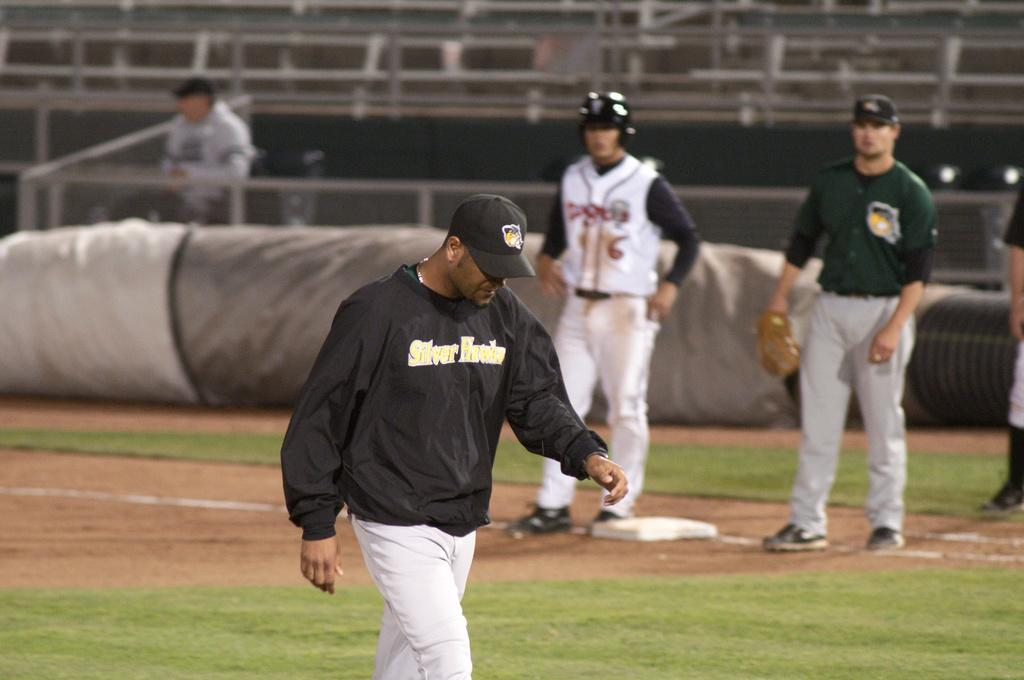<image>
Present a compact description of the photo's key features. A baseball player in a black jacket with Silver Hawks written on the front of it. 